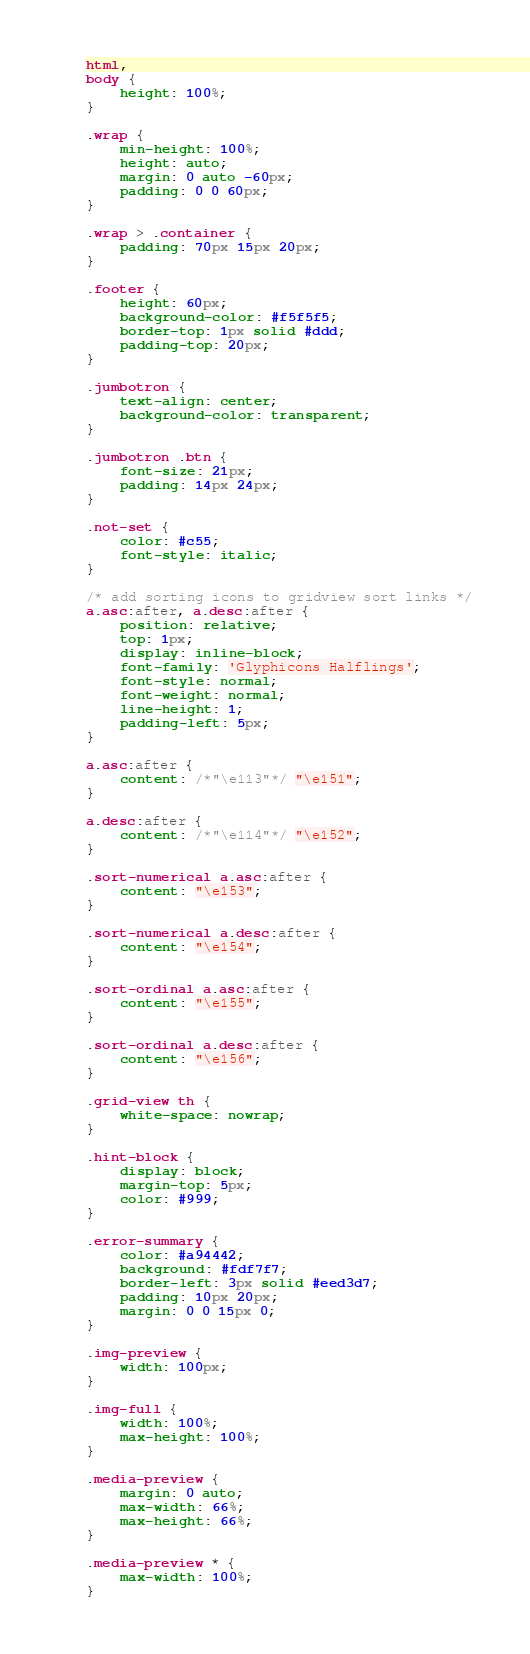Convert code to text. <code><loc_0><loc_0><loc_500><loc_500><_CSS_>html,
body {
    height: 100%;
}

.wrap {
    min-height: 100%;
    height: auto;
    margin: 0 auto -60px;
    padding: 0 0 60px;
}

.wrap > .container {
    padding: 70px 15px 20px;
}

.footer {
    height: 60px;
    background-color: #f5f5f5;
    border-top: 1px solid #ddd;
    padding-top: 20px;
}

.jumbotron {
    text-align: center;
    background-color: transparent;
}

.jumbotron .btn {
    font-size: 21px;
    padding: 14px 24px;
}

.not-set {
    color: #c55;
    font-style: italic;
}

/* add sorting icons to gridview sort links */
a.asc:after, a.desc:after {
    position: relative;
    top: 1px;
    display: inline-block;
    font-family: 'Glyphicons Halflings';
    font-style: normal;
    font-weight: normal;
    line-height: 1;
    padding-left: 5px;
}

a.asc:after {
    content: /*"\e113"*/ "\e151";
}

a.desc:after {
    content: /*"\e114"*/ "\e152";
}

.sort-numerical a.asc:after {
    content: "\e153";
}

.sort-numerical a.desc:after {
    content: "\e154";
}

.sort-ordinal a.asc:after {
    content: "\e155";
}

.sort-ordinal a.desc:after {
    content: "\e156";
}

.grid-view th {
    white-space: nowrap;
}

.hint-block {
    display: block;
    margin-top: 5px;
    color: #999;
}

.error-summary {
    color: #a94442;
    background: #fdf7f7;
    border-left: 3px solid #eed3d7;
    padding: 10px 20px;
    margin: 0 0 15px 0;
}

.img-preview {
    width: 100px;
}

.img-full {
    width: 100%;
    max-height: 100%;
}

.media-preview {
    margin: 0 auto;
    max-width: 66%;
    max-height: 66%;
}

.media-preview * {
    max-width: 100%;
}
</code> 